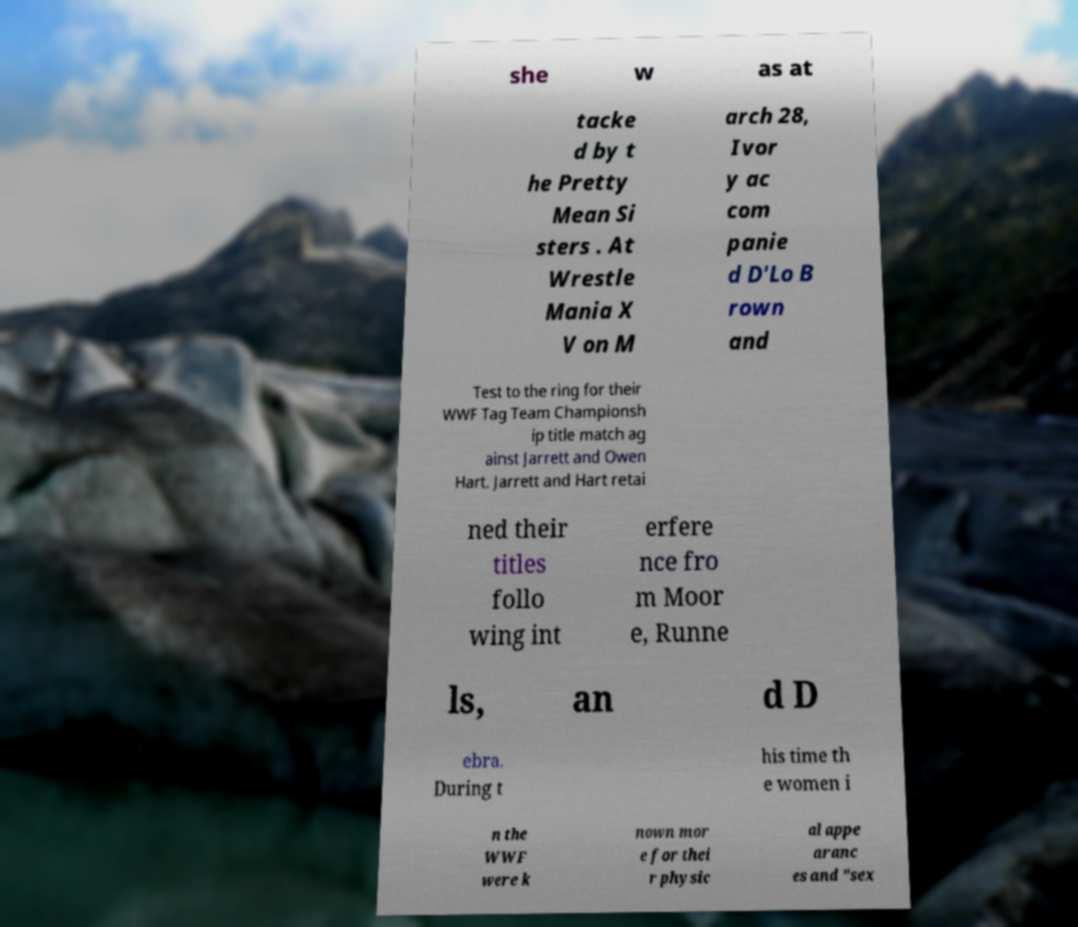I need the written content from this picture converted into text. Can you do that? she w as at tacke d by t he Pretty Mean Si sters . At Wrestle Mania X V on M arch 28, Ivor y ac com panie d D'Lo B rown and Test to the ring for their WWF Tag Team Championsh ip title match ag ainst Jarrett and Owen Hart. Jarrett and Hart retai ned their titles follo wing int erfere nce fro m Moor e, Runne ls, an d D ebra. During t his time th e women i n the WWF were k nown mor e for thei r physic al appe aranc es and "sex 